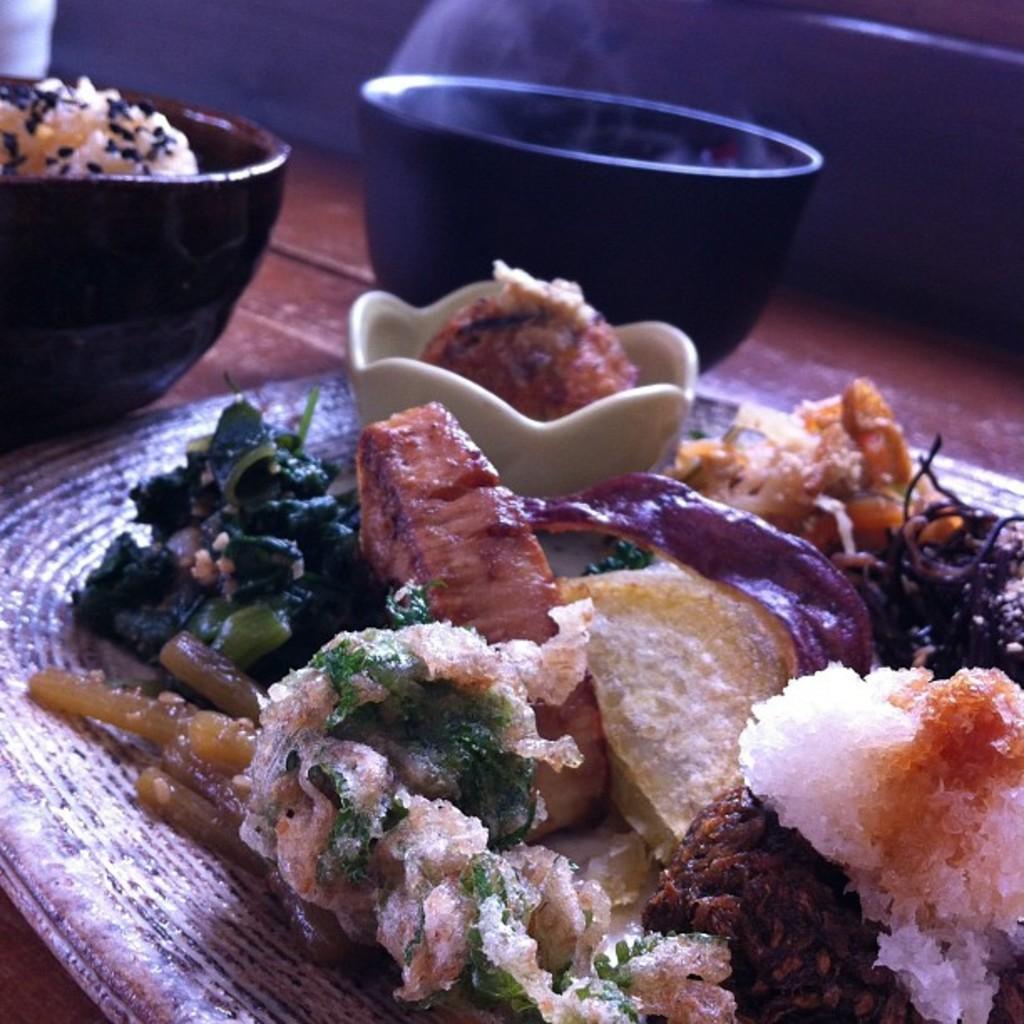Can you describe this image briefly? In this image, there is a table, on that table there is a plate, in that plate there are some food items kept, there are two black color bowls kept on the table. 